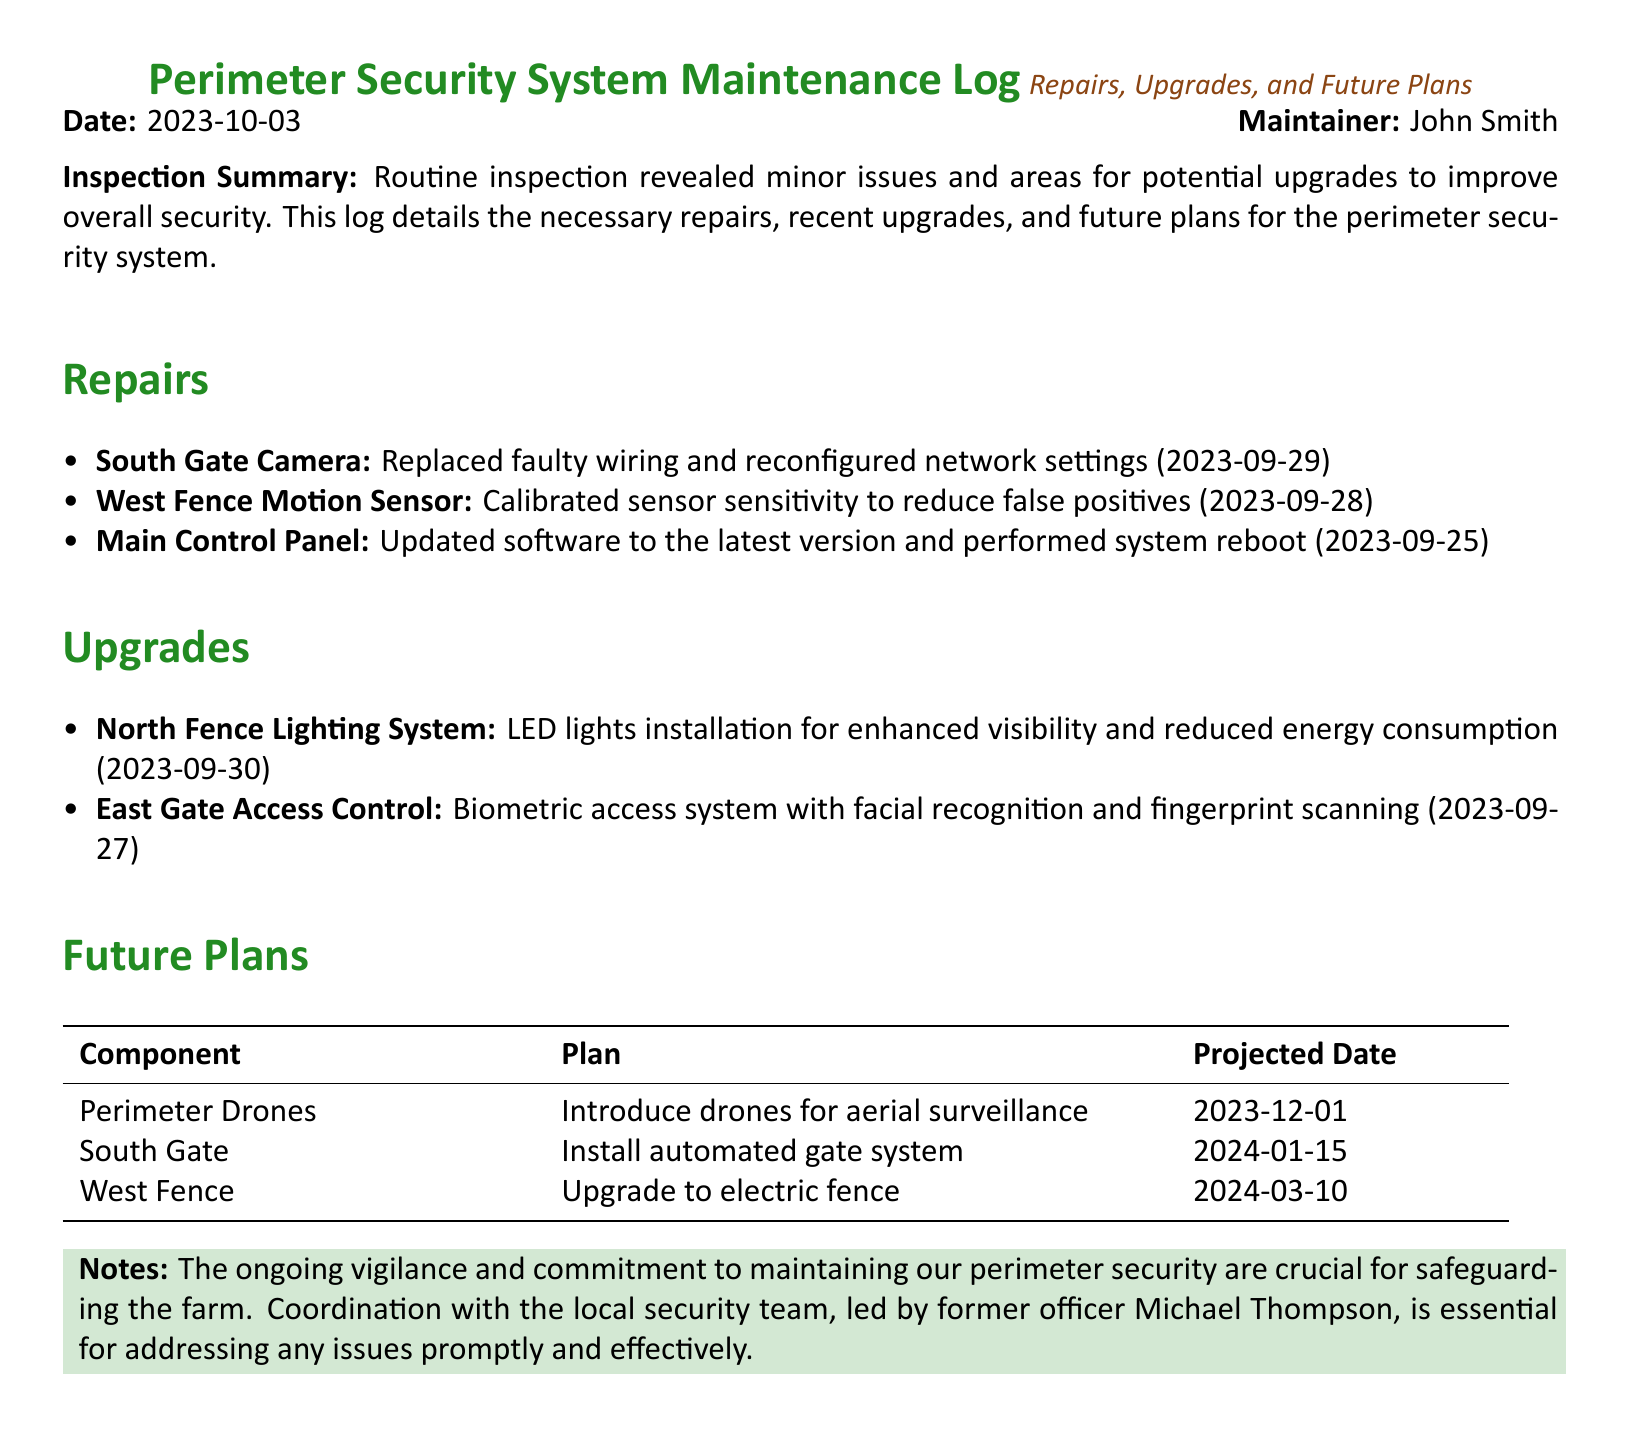what is the date of the maintenance log? The date is specifically stated at the beginning of the document as "2023-10-03".
Answer: 2023-10-03 who is the maintainer of the system? The maintainer's name is mentioned right below the date, which is "John Smith".
Answer: John Smith what component was upgraded on 2023-09-30? The log lists the upgrade for the "North Fence Lighting System" with the installation date.
Answer: North Fence Lighting System how many repairs are listed in the log? By counting the items under the Repairs section, there are three repairs mentioned.
Answer: 3 what is the projected date for introducing perimeter drones? The projected date for this future plan is stated as "2023-12-01".
Answer: 2023-12-01 which system is being installed at the East Gate? The log specifies that a "Biometric access system" is being installed at the East Gate.
Answer: Biometric access system how is the perimeter security currently maintained? The document indicates ongoing vigilance and coordination with the local security team.
Answer: Ongoing vigilance and coordination what significant upgrade is planned for the West Fence? The log outlines a plan to "upgrade to electric fence" for the West Fence.
Answer: Upgrade to electric fence what was updated in the Main Control Panel? The document mentions that the software in the Main Control Panel was updated to the latest version.
Answer: Software updated to the latest version 